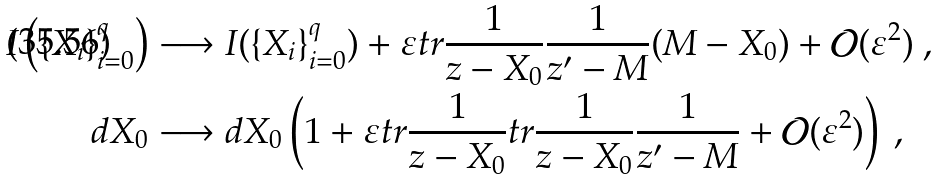<formula> <loc_0><loc_0><loc_500><loc_500>I \left ( \{ X _ { i } \} _ { i = 0 } ^ { q } \right ) & \longrightarrow I ( \{ X _ { i } \} _ { i = 0 } ^ { q } ) + \varepsilon t r \frac { 1 } { z - X _ { 0 } } \frac { 1 } { z ^ { \prime } - M } ( M - X _ { 0 } ) + \mathcal { O } ( \varepsilon ^ { 2 } ) \ , \\ d X _ { 0 } & \longrightarrow d X _ { 0 } \left ( 1 + \varepsilon t r \frac { 1 } { z - X _ { 0 } } t r \frac { 1 } { z - X _ { 0 } } \frac { 1 } { z ^ { \prime } - M } + \mathcal { O } ( \varepsilon ^ { 2 } ) \right ) \ ,</formula> 